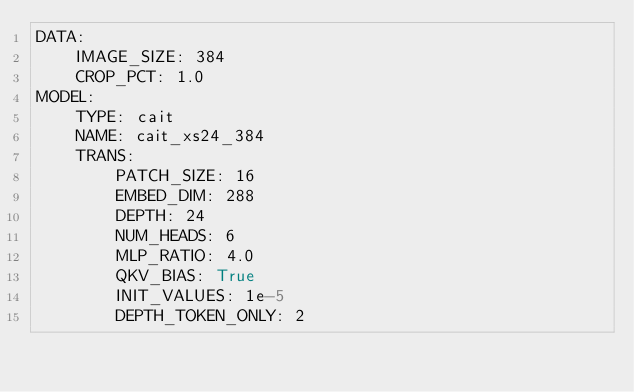<code> <loc_0><loc_0><loc_500><loc_500><_YAML_>DATA:
    IMAGE_SIZE: 384
    CROP_PCT: 1.0
MODEL:
    TYPE: cait
    NAME: cait_xs24_384
    TRANS:
        PATCH_SIZE: 16
        EMBED_DIM: 288
        DEPTH: 24
        NUM_HEADS: 6
        MLP_RATIO: 4.0
        QKV_BIAS: True
        INIT_VALUES: 1e-5
        DEPTH_TOKEN_ONLY: 2
</code> 